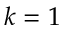<formula> <loc_0><loc_0><loc_500><loc_500>k = 1</formula> 